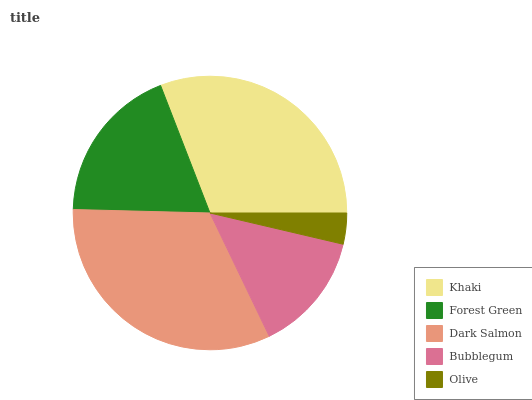Is Olive the minimum?
Answer yes or no. Yes. Is Dark Salmon the maximum?
Answer yes or no. Yes. Is Forest Green the minimum?
Answer yes or no. No. Is Forest Green the maximum?
Answer yes or no. No. Is Khaki greater than Forest Green?
Answer yes or no. Yes. Is Forest Green less than Khaki?
Answer yes or no. Yes. Is Forest Green greater than Khaki?
Answer yes or no. No. Is Khaki less than Forest Green?
Answer yes or no. No. Is Forest Green the high median?
Answer yes or no. Yes. Is Forest Green the low median?
Answer yes or no. Yes. Is Olive the high median?
Answer yes or no. No. Is Bubblegum the low median?
Answer yes or no. No. 